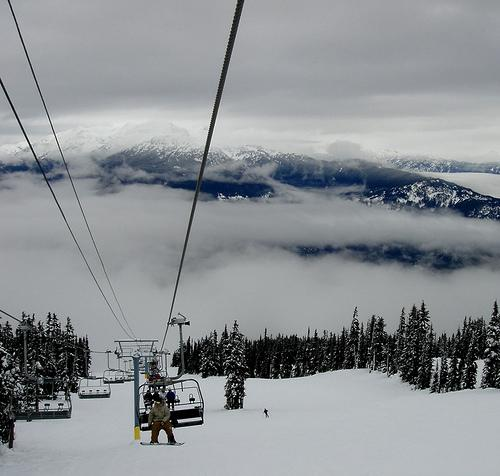Where does the carrier take the man to?

Choices:
A) right
B) uphill
C) downhill
D) left uphill 